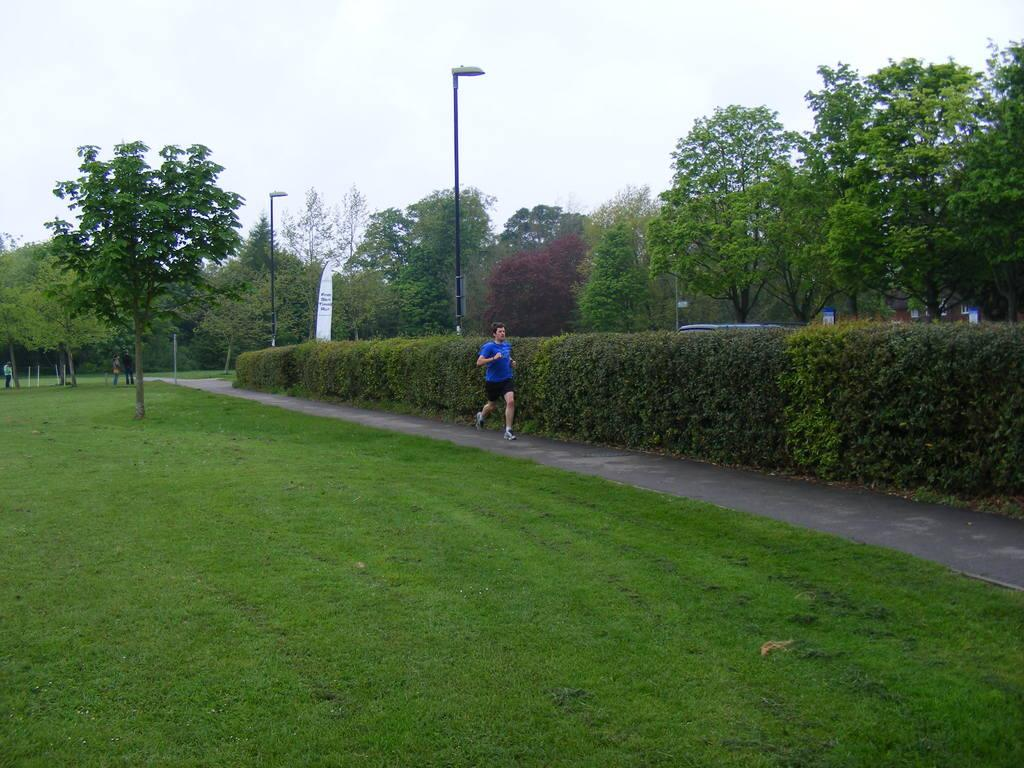What is the man in the image doing? The man is running in the image. Where is the man running? The man is running on a path. What can be seen in the background of the image? There are plants, poles, trees, and the sky visible in the image. Are there any other people in the image? Yes, there are people standing on the path in the image. What type of punishment is the toad receiving in the image? There is no toad present in the image, and therefore no punishment can be observed. How many drops of water can be seen falling from the sky in the image? The image does not show any drops of water falling from the sky; it only shows the sky visible behind the trees. 